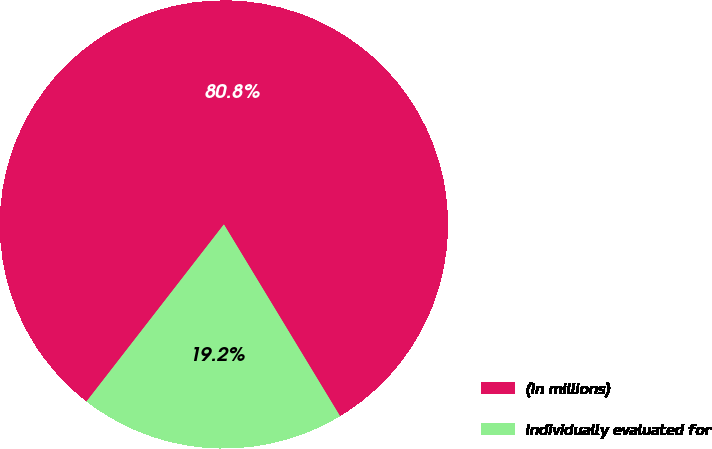Convert chart. <chart><loc_0><loc_0><loc_500><loc_500><pie_chart><fcel>(In millions)<fcel>Individually evaluated for<nl><fcel>80.83%<fcel>19.17%<nl></chart> 